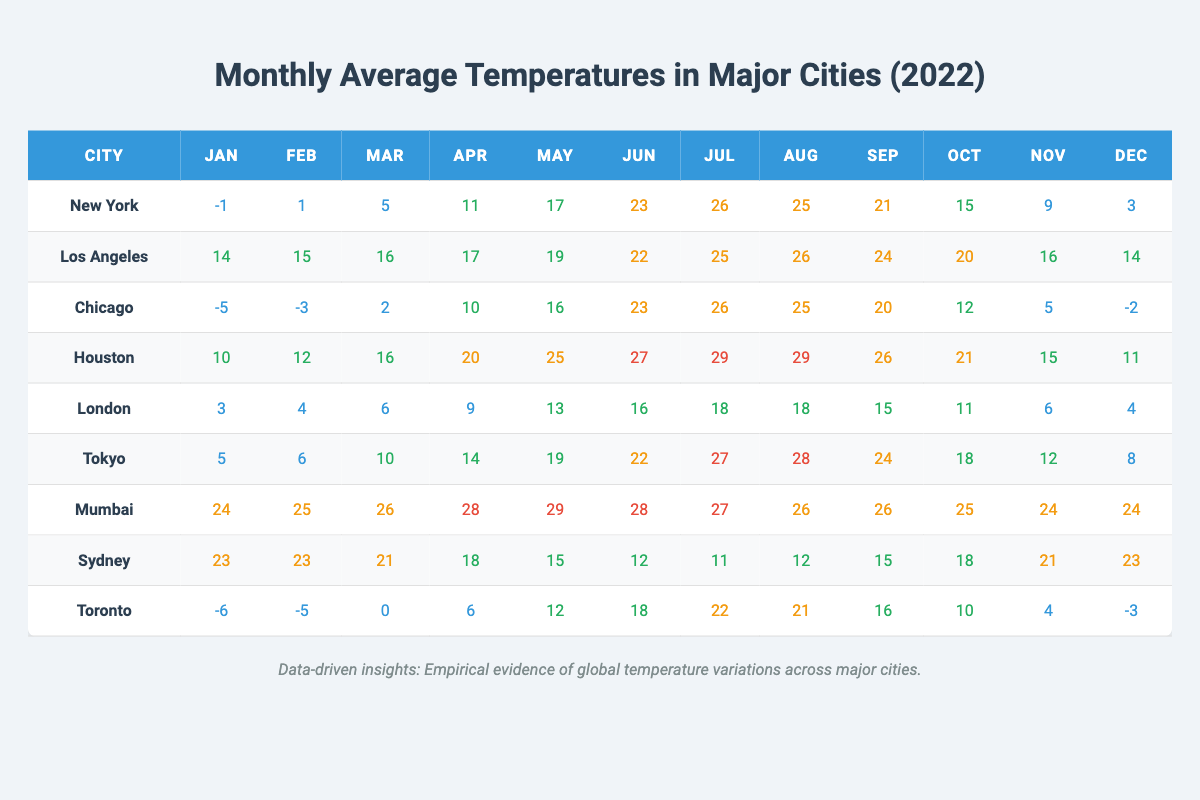What is the average temperature in July for all the cities? First, sum the July temperatures for each city: New York (26) + Los Angeles (25) + Chicago (26) + Houston (29) + London (18) + Tokyo (27) + Mumbai (27) + Sydney (11) + Toronto (22) =  27 + 22 + 26 + 25 + 29 + 18 + 27 + 11 = 210. Then, divide by the number of cities (9): 210 / 9 = 23.33
Answer: 23.33 Which city had the highest temperature in February? In the table, look at the February temperatures: New York (1), Los Angeles (15), Chicago (-3), Houston (12), London (4), Tokyo (6), Mumbai (25), Sydney (23), Toronto (-5). The maximum value is Mumbai (25).
Answer: Mumbai Is it true that London has a lower average temperature than Sydney for the year? Calculate the average for London: (3 + 4 + 6 + 9 + 13 + 16 + 18 + 18 + 15 + 11 + 6 + 4) = 115 / 12 = 9.58. Now calculate for Sydney: (23 + 23 + 21 + 18 + 15 + 12 + 11 + 12 + 15 + 18 + 21 + 23) =  18 + 21 + 23 + 19 + 15 + 18 + 18 + 15 = 210 / 12 = 17.5. Since 9.58 < 17.5, it is true that London is lower.
Answer: Yes Which city experiences the most drastic temperature change from January to July? Look at the temperature change for each city: New York (from -1 to 26, a change of 27), Los Angeles (14 to 25, a change of 11), Chicago (-5 to 26, a change of 31), Houston (10 to 29, a change of 19), London (3 to 18, a change of 15), Tokyo (5 to 27, a change of 22), Mumbai (24 to 27, a change of 3), Sydney (23 to 11, a change of 12), Toronto (-6 to 22, a change of 28). The largest change is Chicago with 31.
Answer: Chicago What is the lowest temperature recorded in January across the cities? Check the January temperatures: New York (-1), Los Angeles (14), Chicago (-5), Houston (10), London (3), Tokyo (5), Mumbai (24), Sydney (23), Toronto (-6). The minimum is from Toronto at -6.
Answer: -6 